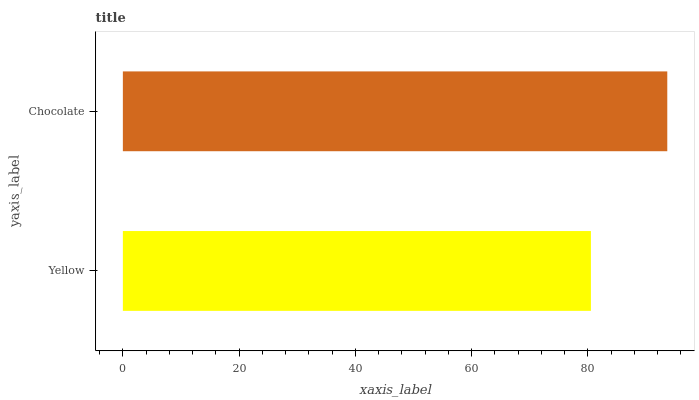Is Yellow the minimum?
Answer yes or no. Yes. Is Chocolate the maximum?
Answer yes or no. Yes. Is Chocolate the minimum?
Answer yes or no. No. Is Chocolate greater than Yellow?
Answer yes or no. Yes. Is Yellow less than Chocolate?
Answer yes or no. Yes. Is Yellow greater than Chocolate?
Answer yes or no. No. Is Chocolate less than Yellow?
Answer yes or no. No. Is Chocolate the high median?
Answer yes or no. Yes. Is Yellow the low median?
Answer yes or no. Yes. Is Yellow the high median?
Answer yes or no. No. Is Chocolate the low median?
Answer yes or no. No. 